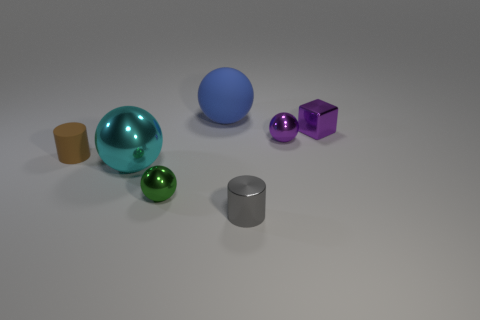What is the material of the big blue object that is the same shape as the tiny green metallic object?
Provide a short and direct response. Rubber. What is the color of the small metal cube?
Offer a very short reply. Purple. What number of things are yellow rubber things or tiny metal blocks?
Give a very brief answer. 1. What is the shape of the rubber thing behind the tiny ball to the right of the metallic cylinder?
Provide a short and direct response. Sphere. What number of other things are the same material as the big cyan ball?
Offer a terse response. 4. Are the large blue thing and the big object that is in front of the purple shiny block made of the same material?
Make the answer very short. No. How many objects are small shiny objects on the right side of the cyan ball or balls to the left of the green metal ball?
Ensure brevity in your answer.  5. How many other things are there of the same color as the small block?
Provide a short and direct response. 1. Is the number of big blue matte things that are behind the tiny purple metallic cube greater than the number of large matte things that are in front of the brown rubber cylinder?
Give a very brief answer. Yes. What number of spheres are big blue objects or gray things?
Offer a terse response. 1. 